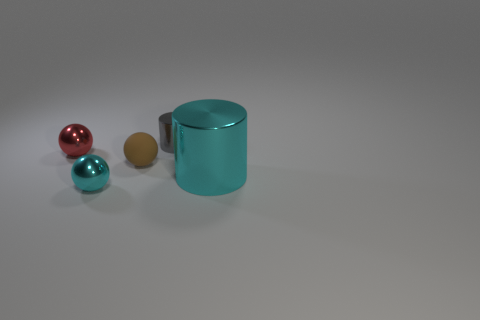Subtract all rubber balls. How many balls are left? 2 Subtract all brown spheres. How many spheres are left? 2 Subtract 1 cylinders. How many cylinders are left? 1 Subtract all spheres. How many objects are left? 2 Subtract all cyan cylinders. Subtract all green balls. How many cylinders are left? 1 Subtract all green balls. How many red cylinders are left? 0 Add 4 small balls. How many small balls are left? 7 Add 5 cyan matte cylinders. How many cyan matte cylinders exist? 5 Add 4 red objects. How many objects exist? 9 Subtract 1 cyan cylinders. How many objects are left? 4 